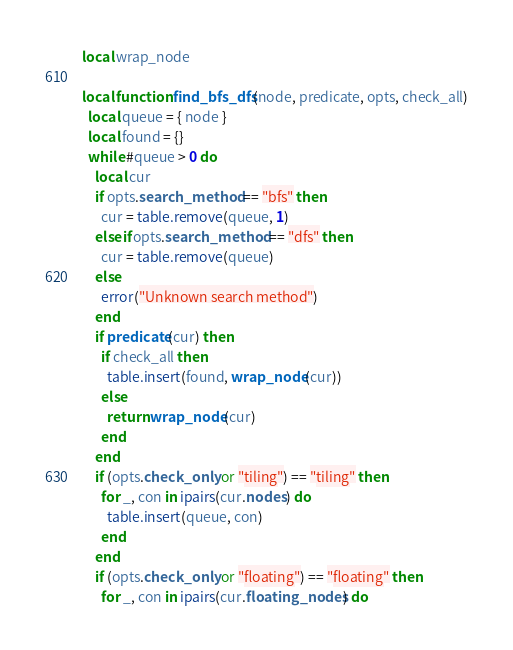<code> <loc_0><loc_0><loc_500><loc_500><_Lua_>local wrap_node

local function find_bfs_dfs(node, predicate, opts, check_all)
  local queue = { node }
  local found = {}
  while #queue > 0 do
    local cur
    if opts.search_method == "bfs" then
      cur = table.remove(queue, 1)
    elseif opts.search_method == "dfs" then
      cur = table.remove(queue)
    else
      error("Unknown search method")
    end
    if predicate(cur) then
      if check_all then
        table.insert(found, wrap_node(cur))
      else
        return wrap_node(cur)
      end
    end
    if (opts.check_only or "tiling") == "tiling" then
      for _, con in ipairs(cur.nodes) do
        table.insert(queue, con)
      end
    end
    if (opts.check_only or "floating") == "floating" then
      for _, con in ipairs(cur.floating_nodes) do</code> 